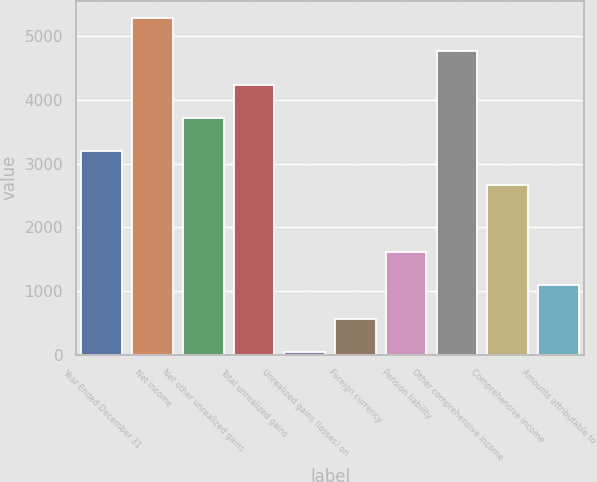Convert chart to OTSL. <chart><loc_0><loc_0><loc_500><loc_500><bar_chart><fcel>Year Ended December 31<fcel>Net income<fcel>Net other unrealized gains<fcel>Total unrealized gains<fcel>Unrealized gains (losses) on<fcel>Foreign currency<fcel>Pension liability<fcel>Other comprehensive income<fcel>Comprehensive income<fcel>Amounts attributable to<nl><fcel>3192.2<fcel>5293<fcel>3717.4<fcel>4242.6<fcel>41<fcel>566.2<fcel>1616.6<fcel>4767.8<fcel>2667<fcel>1091.4<nl></chart> 